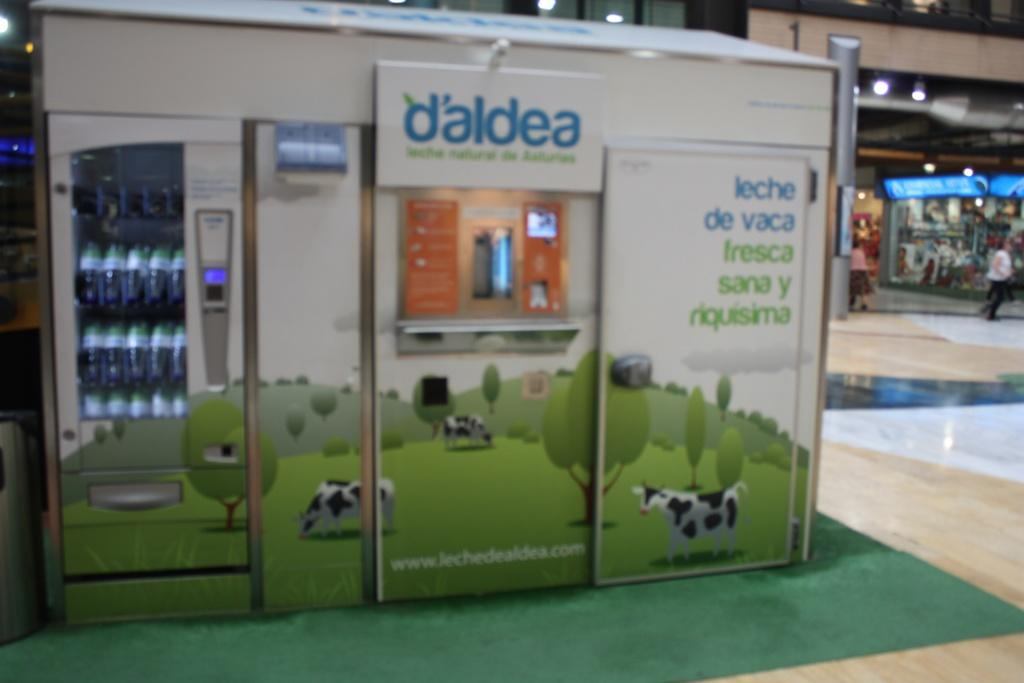What is the main object in the image? There is a vending machine in the image. Can you describe the surroundings of the vending machine? There are people in the background of the image. What can be seen illuminating the area in the image? There are lights visible in the image. What type of lunch is being served in the image? There is no lunch present in the image; it features a vending machine and people in the background. Can you tell me how many cacti are visible in the image? There are no cacti present in the image. 